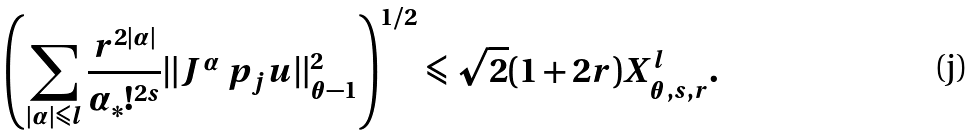Convert formula to latex. <formula><loc_0><loc_0><loc_500><loc_500>\left ( \sum _ { | \alpha | \leqslant { l } } \frac { r ^ { 2 | \alpha | } } { \alpha _ { \ast } ! ^ { 2 s } } \| { J ^ { \alpha } } \ p _ { j } u \| _ { \theta - 1 } ^ { 2 } \right ) ^ { 1 / 2 } \leqslant \sqrt { 2 } ( 1 + 2 r ) X ^ { l } _ { \theta , s , r } .</formula> 